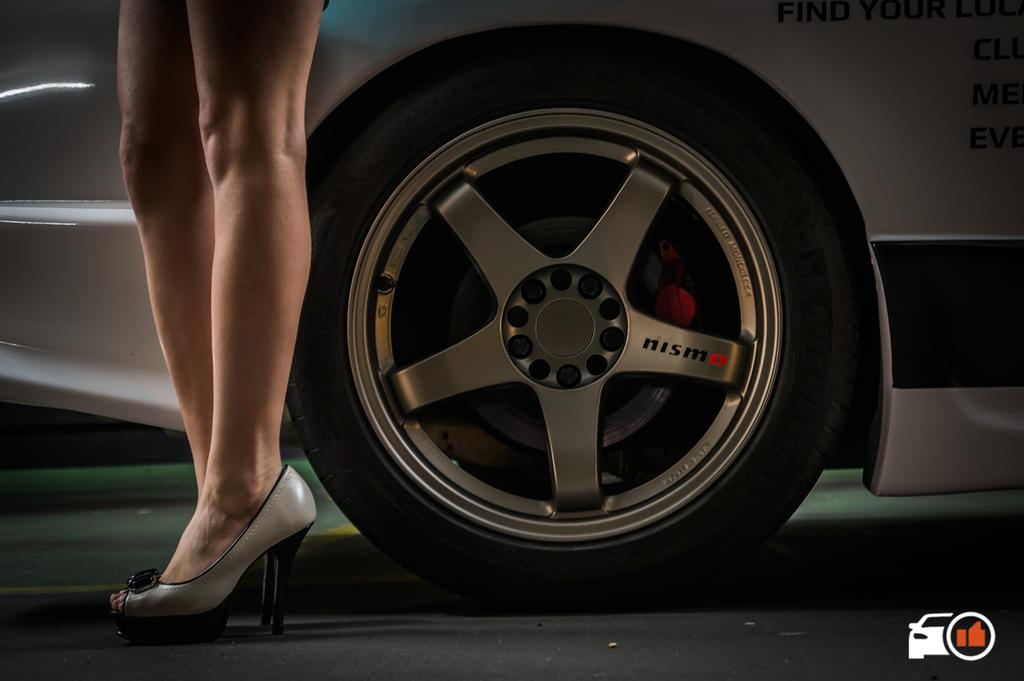What can be seen at the bottom right side of the image? There is a logo in the bottom right side of the image. What type of object is visible on the surface in the image? There is a vehicle on the surface in the image. What part of a person can be seen in the image? Legs with footwear are visible in the image. How many ears can be seen in the image? There are no ears visible in the image. What type of vessel is present in the image? There is no vessel present in the image. 